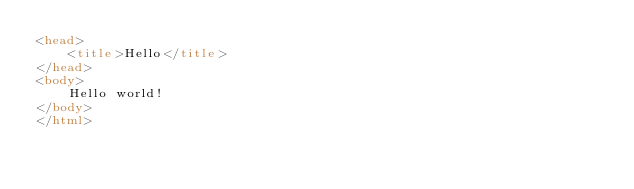<code> <loc_0><loc_0><loc_500><loc_500><_HTML_><head>
	<title>Hello</title>
</head>
<body>
	Hello world!
</body>
</html></code> 